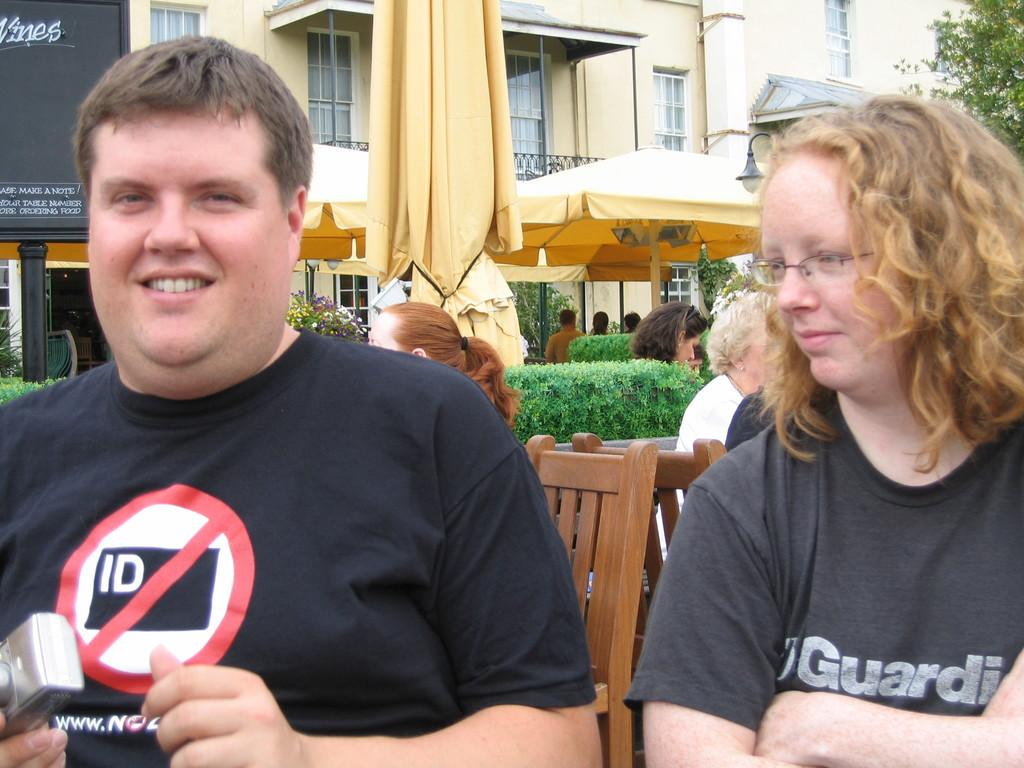Provide a one-sentence caption for the provided image. Two people wearing black t shirts and one has ID on it. 